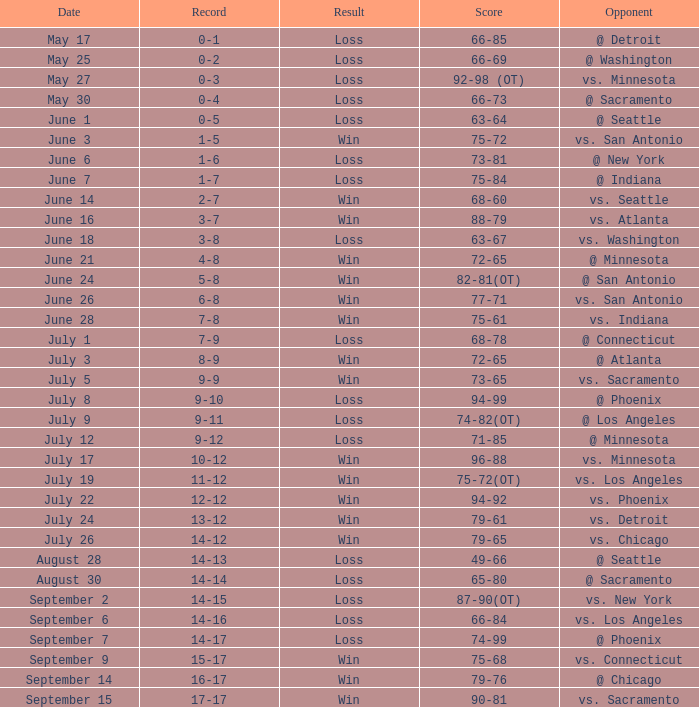What was the Result on July 24? Win. 